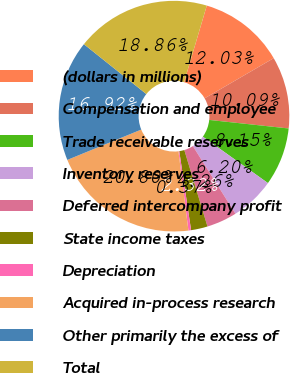<chart> <loc_0><loc_0><loc_500><loc_500><pie_chart><fcel>(dollars in millions)<fcel>Compensation and employee<fcel>Trade receivable reserves<fcel>Inventory reserves<fcel>Deferred intercompany profit<fcel>State income taxes<fcel>Depreciation<fcel>Acquired in-process research<fcel>Other primarily the excess of<fcel>Total<nl><fcel>12.03%<fcel>10.09%<fcel>8.15%<fcel>6.2%<fcel>4.26%<fcel>2.32%<fcel>0.37%<fcel>20.8%<fcel>16.92%<fcel>18.86%<nl></chart> 